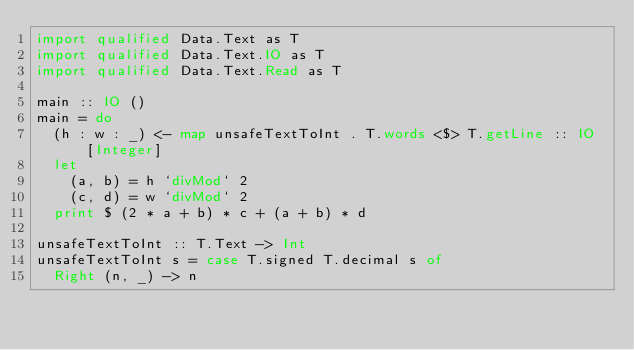Convert code to text. <code><loc_0><loc_0><loc_500><loc_500><_Haskell_>import qualified Data.Text as T
import qualified Data.Text.IO as T
import qualified Data.Text.Read as T

main :: IO ()
main = do
  (h : w : _) <- map unsafeTextToInt . T.words <$> T.getLine :: IO [Integer]
  let
    (a, b) = h `divMod` 2
    (c, d) = w `divMod` 2
  print $ (2 * a + b) * c + (a + b) * d

unsafeTextToInt :: T.Text -> Int
unsafeTextToInt s = case T.signed T.decimal s of
  Right (n, _) -> n
</code> 